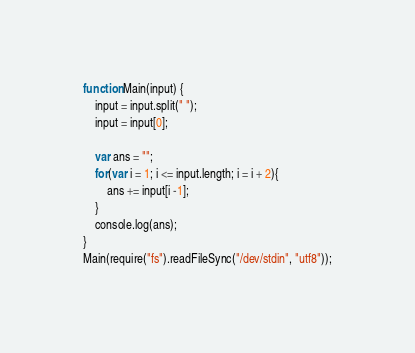Convert code to text. <code><loc_0><loc_0><loc_500><loc_500><_JavaScript_>function Main(input) {
	input = input.split(" ");
    input = input[0];
    
    var ans = "";	
	for(var i = 1; i <= input.length; i = i + 2){
	    ans += input[i -1]; 
	}
    console.log(ans);
}
Main(require("fs").readFileSync("/dev/stdin", "utf8"));
</code> 